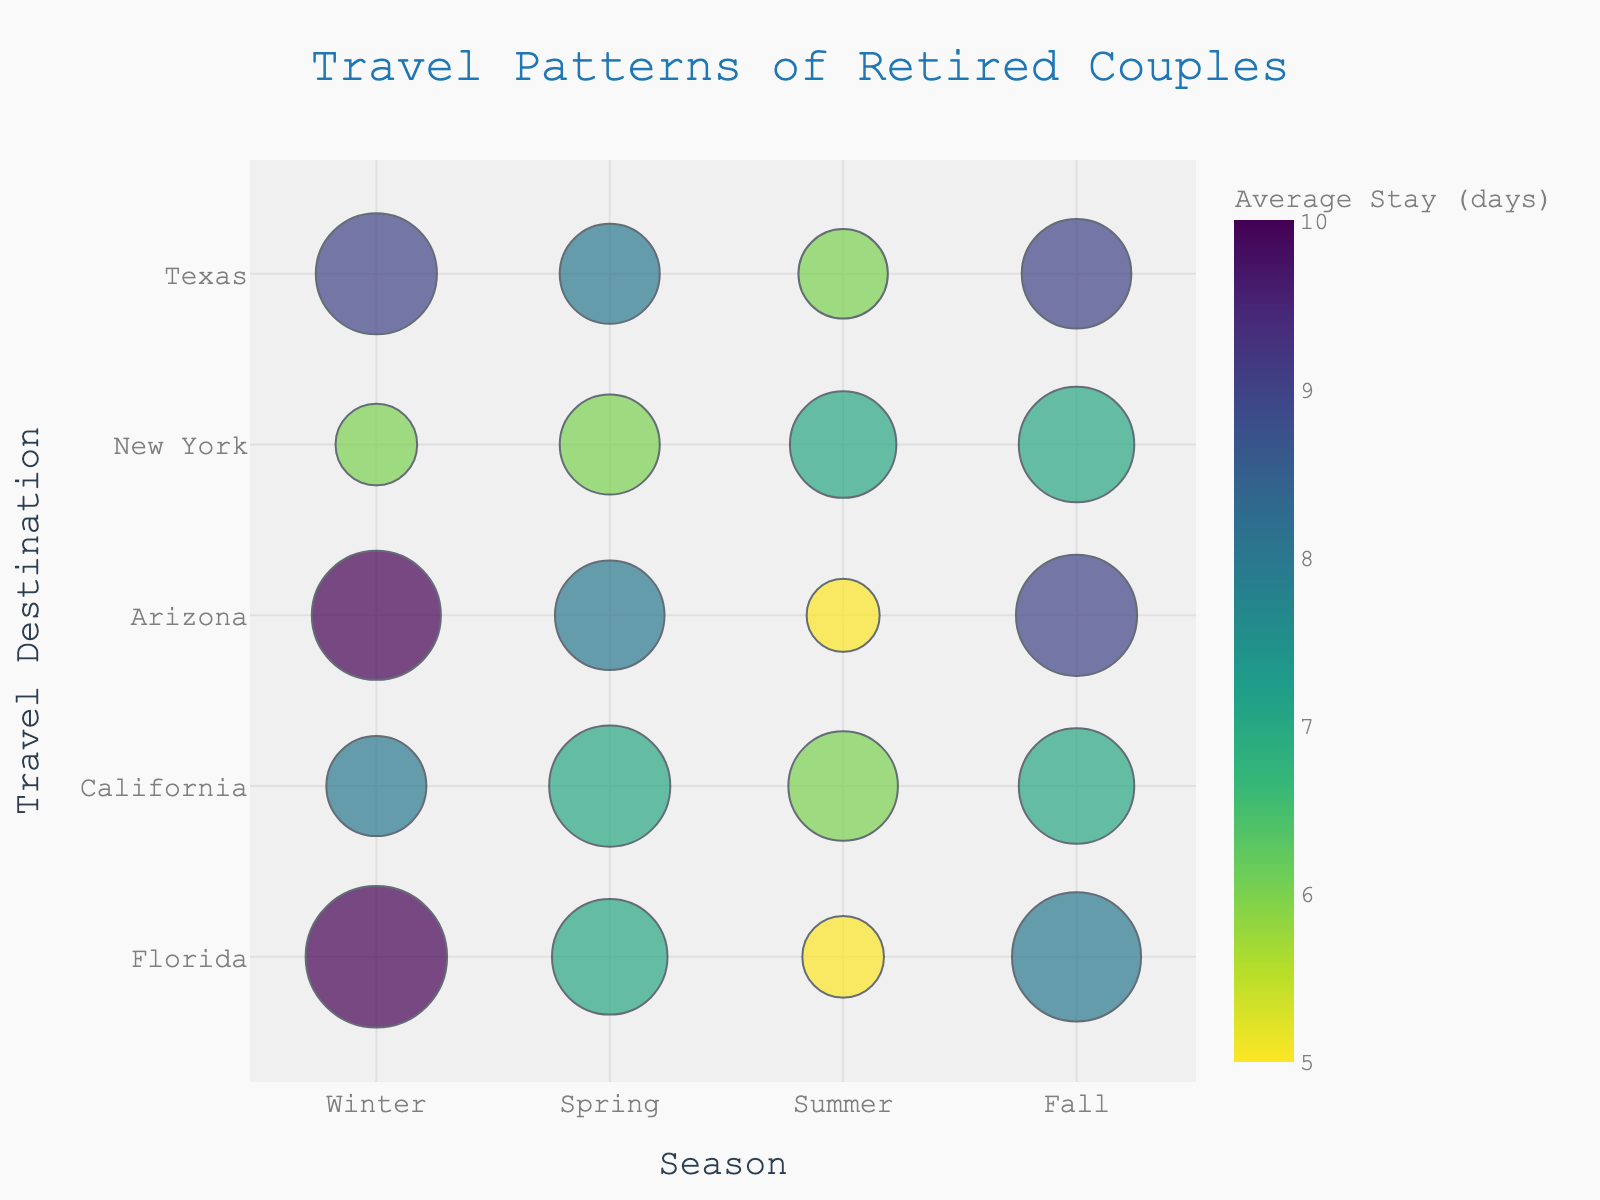what is the most frequent travel destination in the winter? To find the most frequent travel destination in the winter, look at the "Winter" column and compare the sizes of the bubbles across different destinations. The largest bubble represents the highest frequency.
Answer: Florida which destination has the longest average stay in the spring? To determine which destination has the longest average stay in the spring, look at the "Spring" column and observe the color of the bubbles. The darker bubble indicates a longer stay.
Answer: Texas how does the travel frequency of California in the summer compare to Arizona in the summer? To compare the travel frequency, look at the bubble sizes in the "Summer" column for both California and Arizona. The larger bubble indicates a higher frequency.
Answer: California has a higher frequency than Arizona which season has the highest total travel frequency for New York? To find the season with the highest total travel frequency for New York, compare the sizes of the bubbles across all seasons. Sum the sizes if necessary across each season.
Answer: Fall How do the average stays in Florida compare across the seasons? To compare the average stays in Florida, observe the color of the bubbles for Florida across all four seasons. The different shades represent different average durations of stay.
Answer: Winter and Fall have the longest, followed by Spring, then Summer If we add the travel frequencies for Texas in the Spring and Fall, what do we get? To calculate the total, add the sizes of the bubbles for Texas in the "Spring" and "Fall" columns.
Answer: 15(Spring) + 18(Fall) = 33 Which travel destination sees the least visitors in the Summer? To determine the least visited destination in the summer, look at the "Summer" column and identify the smallest bubble.
Answer: Arizona What is the trend of visiting Arizona across the seasons? To determine the trend in Arizona, examine the sizes and colors of the bubbles for Arizona across all seasons. Look for any increase/decrease in size and changes in color.
Answer: High in Winter, decreases in Spring, lowest in Summer, increases in Fall 